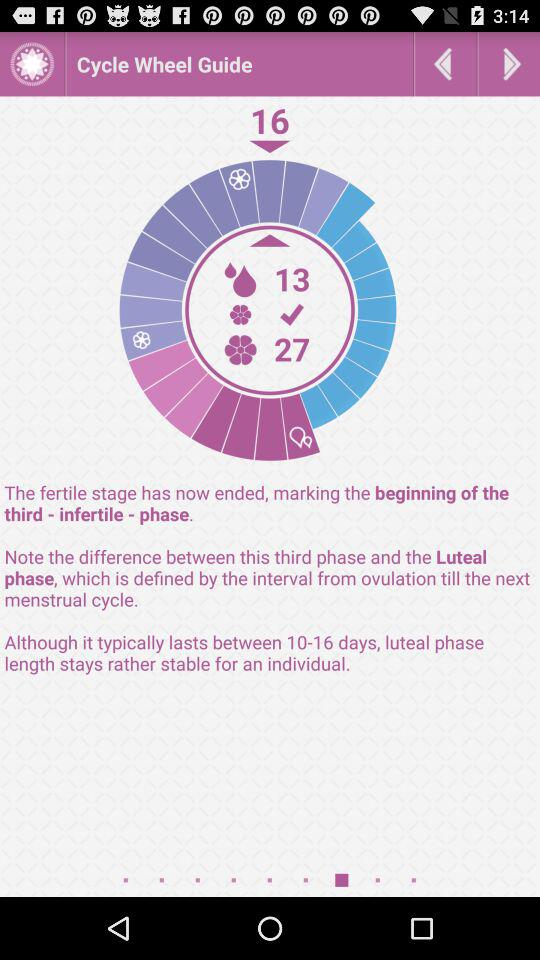What is the application name? The application name is Cycle Wheel Guide. 